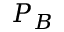<formula> <loc_0><loc_0><loc_500><loc_500>P _ { B }</formula> 